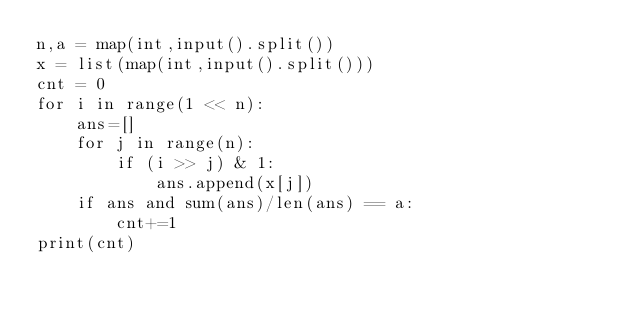<code> <loc_0><loc_0><loc_500><loc_500><_Python_>n,a = map(int,input().split())
x = list(map(int,input().split()))
cnt = 0
for i in range(1 << n):
    ans=[]
    for j in range(n):
        if (i >> j) & 1:
            ans.append(x[j])
    if ans and sum(ans)/len(ans) == a:
        cnt+=1
print(cnt)</code> 